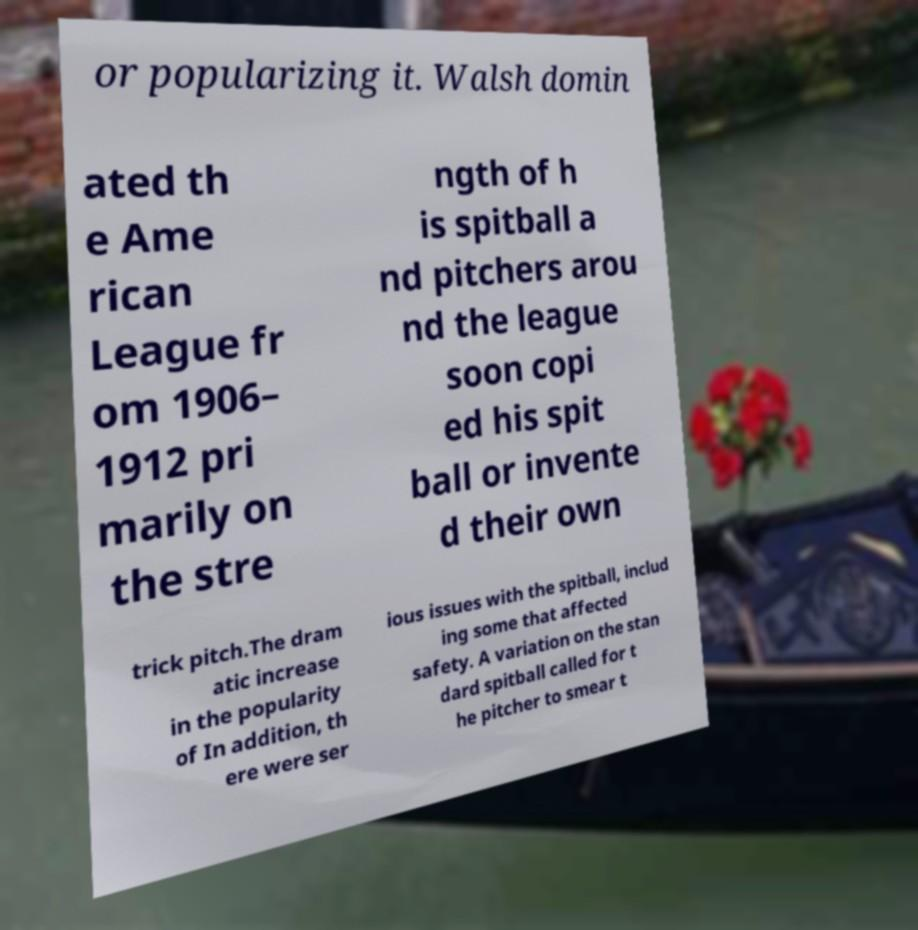Could you extract and type out the text from this image? or popularizing it. Walsh domin ated th e Ame rican League fr om 1906– 1912 pri marily on the stre ngth of h is spitball a nd pitchers arou nd the league soon copi ed his spit ball or invente d their own trick pitch.The dram atic increase in the popularity of In addition, th ere were ser ious issues with the spitball, includ ing some that affected safety. A variation on the stan dard spitball called for t he pitcher to smear t 